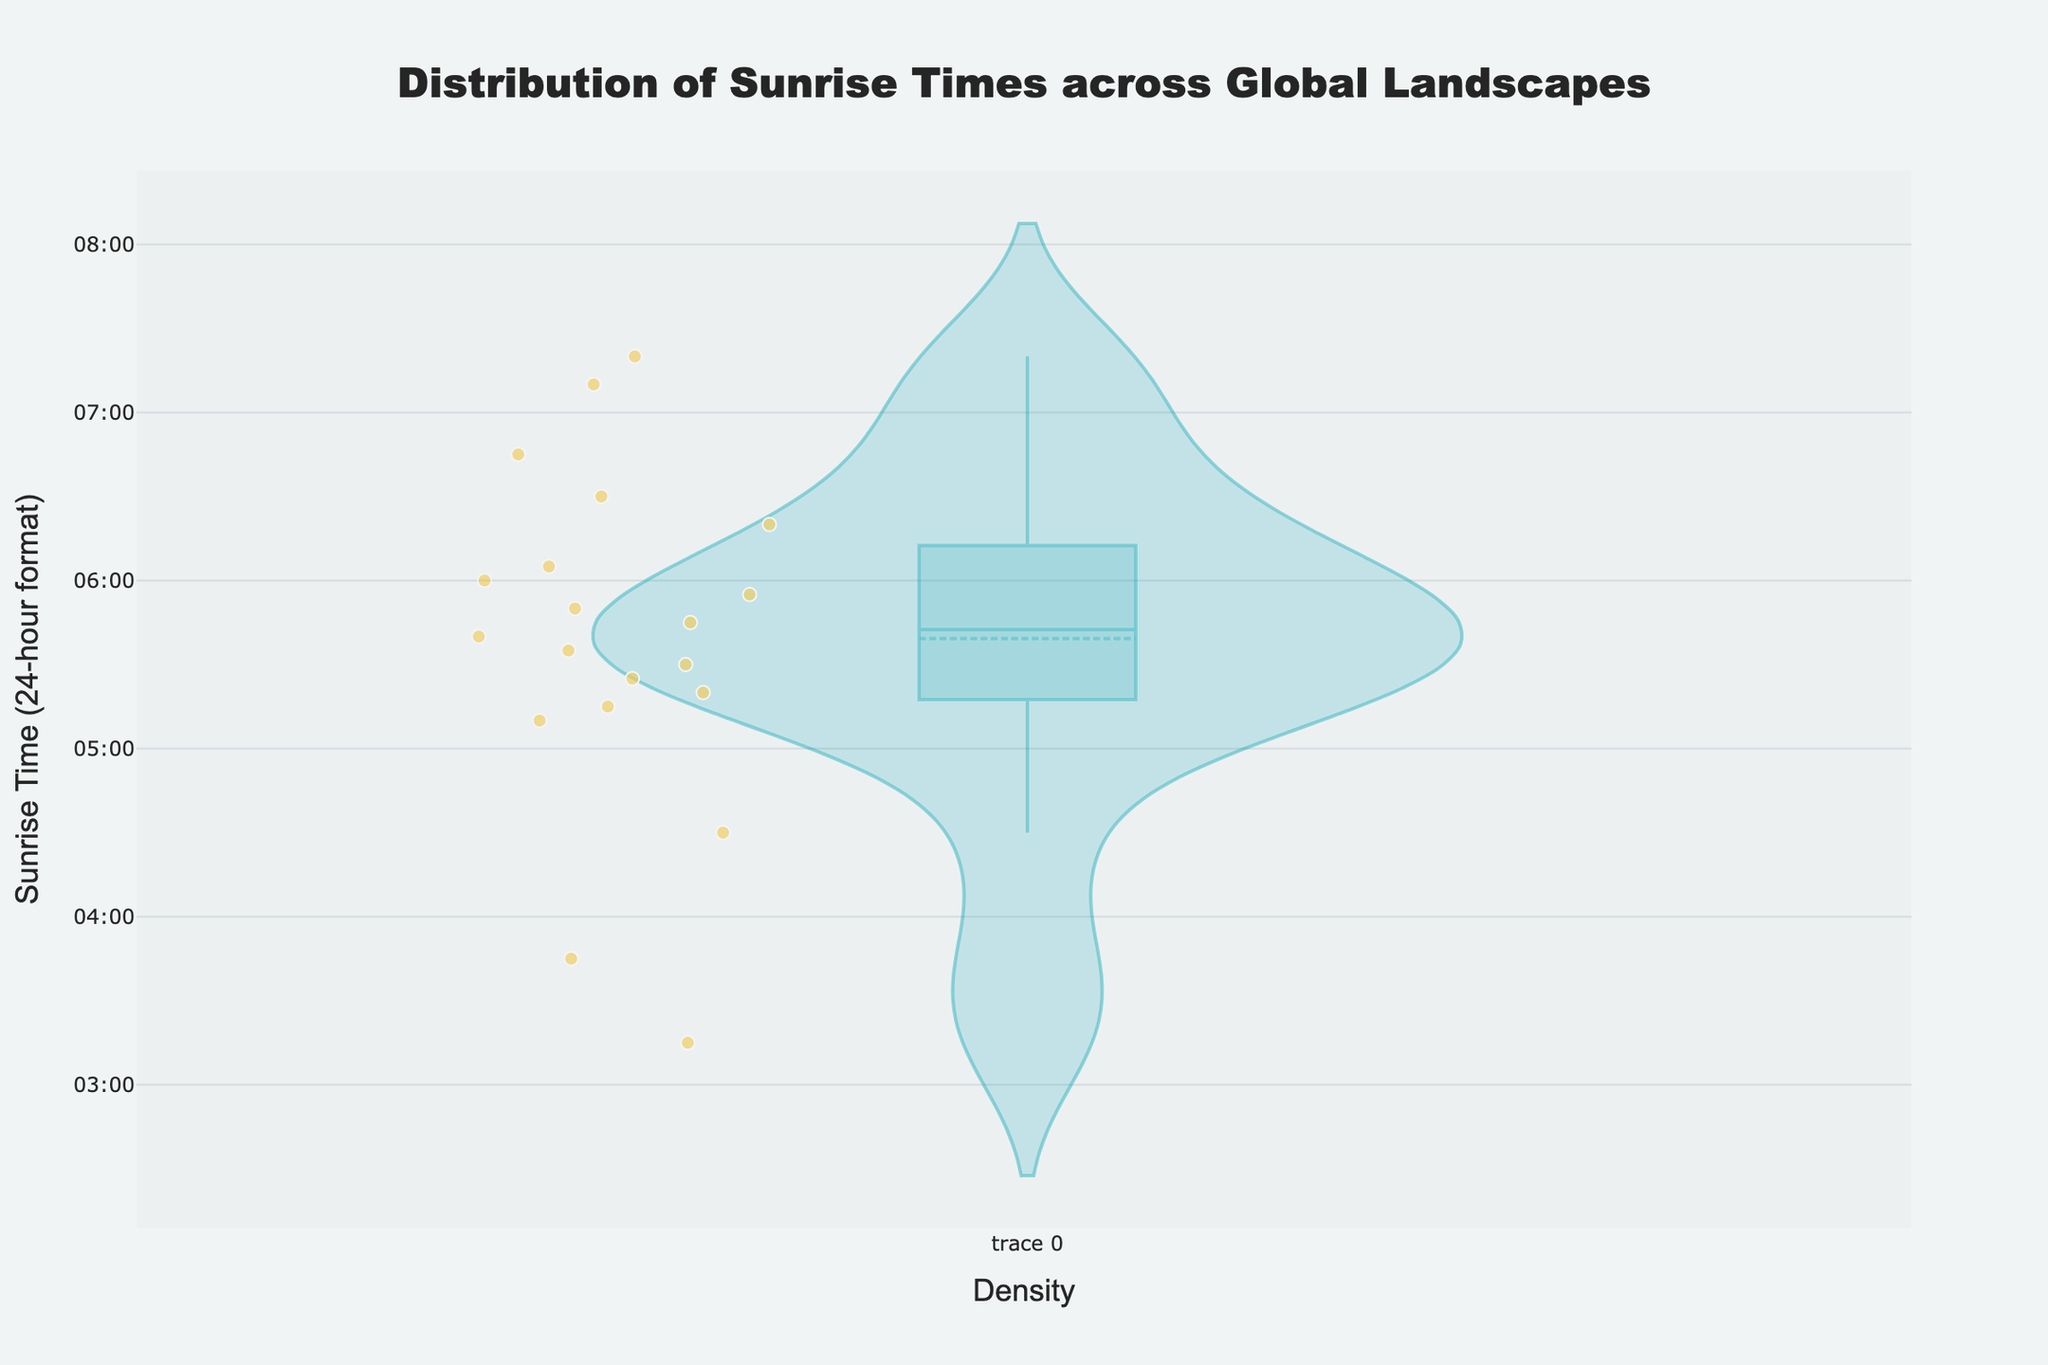What is the title of the figure? The title is shown at the top of the figure and gives an overview of what the plot is about.
Answer: Distribution of Sunrise Times across Global Landscapes What is the range of the y-axis on the plot? The y-axis range can be identified by looking at the scale provided on the y-axis, which shows time intervals.
Answer: 03:00 to 08:00 How many landscapes have sunrise times before 5:00 AM? Count the number of individual points on the violin plot that are below 5:00 on the y-axis.
Answer: 3 Which landscape has the earliest sunrise time shown? By observing the lowest point on the violin plot and looking at the hover text, we can identify the earliest sunrise.
Answer: Iceland's Golden Circle What is the average sunrise time across all landscapes? To find the average, sum the sunrise times (in decimal hours) and divide by the number of data points.
Answer: 5.92 (5:55) Which landscape has the latest sunrise time? By observing the highest point on the violin plot and looking at the hover text, we can identify the latest sunrise.
Answer: Fiordland Is the distribution of sunrise times skewed towards earlier or later times? Assess the density and concentration of data points within the violin plot. If more points are concentrated toward the lower end of the y-axis, it is skewed earlier; otherwise, later.
Answer: Skewed earlier Are there any outliers in the sunrise times? Identify any data points that are significantly separated from the bulk of the data within the violin plot.
Answer: Yes, Iceland's Golden Circle and Faroe Islands What is the median sunrise time? The median is the middle value in the list of sunrise times. It can often be identified by the position of the mean line within the violin plot.
Answer: 5:45 